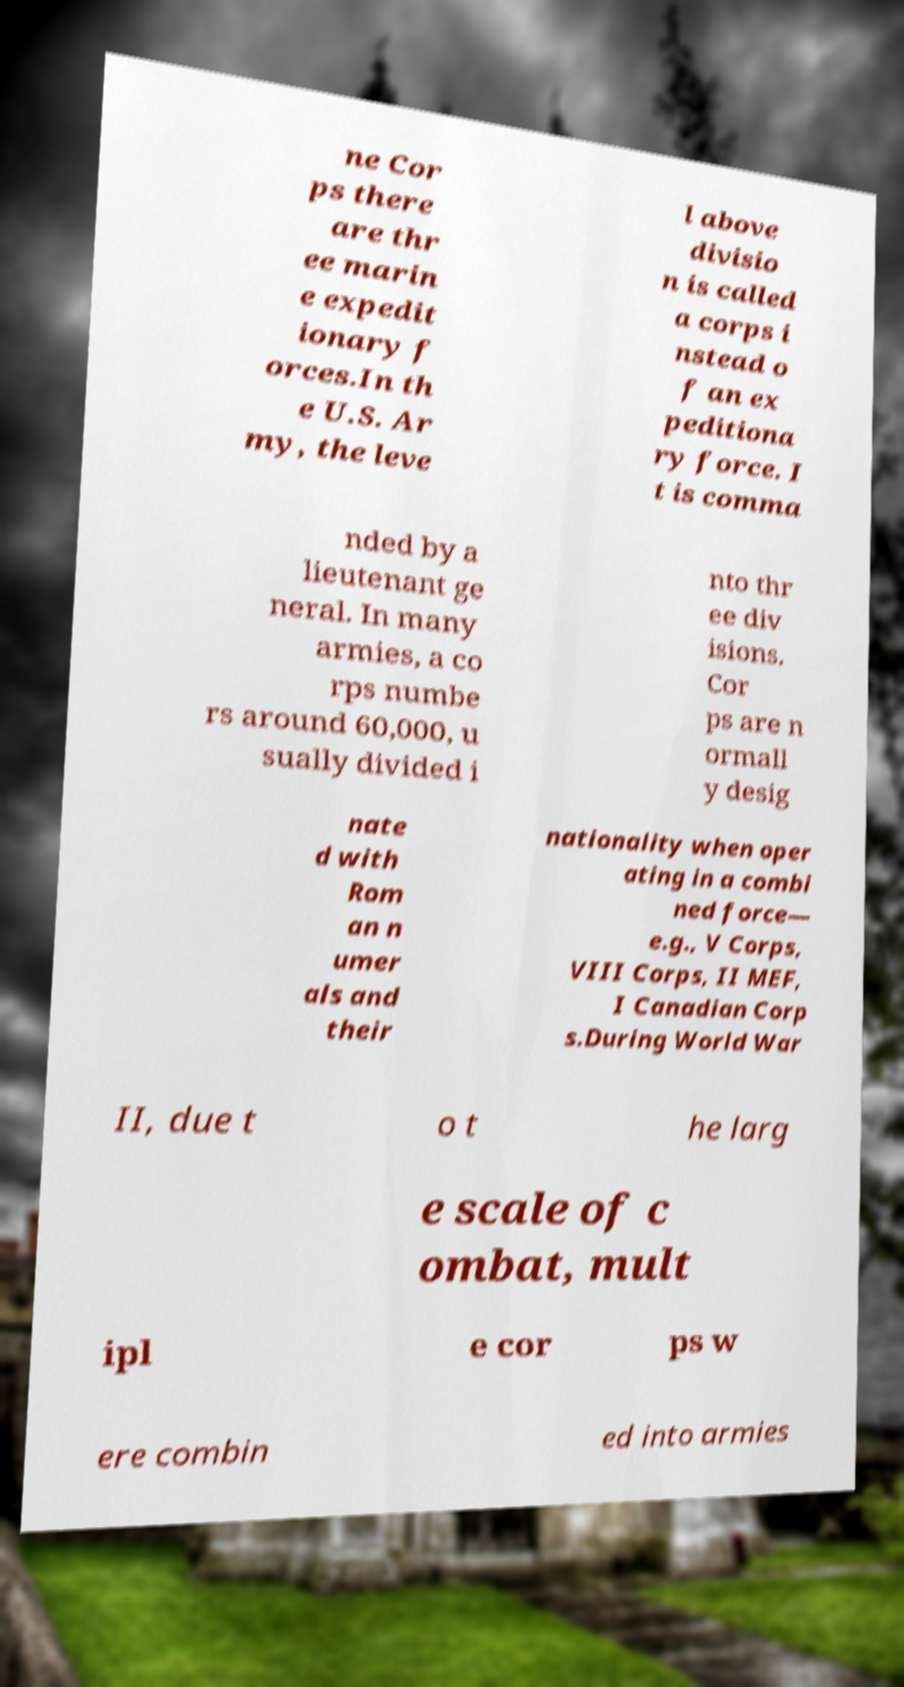Can you read and provide the text displayed in the image?This photo seems to have some interesting text. Can you extract and type it out for me? ne Cor ps there are thr ee marin e expedit ionary f orces.In th e U.S. Ar my, the leve l above divisio n is called a corps i nstead o f an ex peditiona ry force. I t is comma nded by a lieutenant ge neral. In many armies, a co rps numbe rs around 60,000, u sually divided i nto thr ee div isions. Cor ps are n ormall y desig nate d with Rom an n umer als and their nationality when oper ating in a combi ned force— e.g., V Corps, VIII Corps, II MEF, I Canadian Corp s.During World War II, due t o t he larg e scale of c ombat, mult ipl e cor ps w ere combin ed into armies 